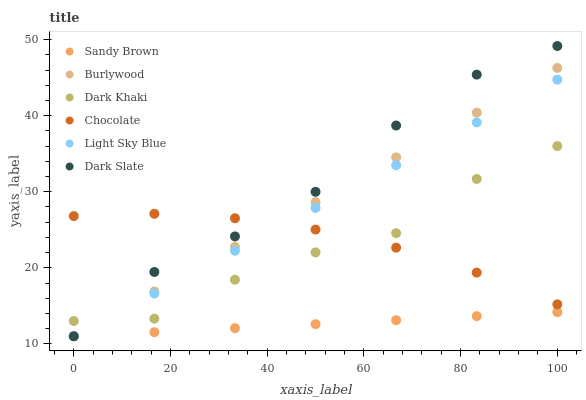Does Sandy Brown have the minimum area under the curve?
Answer yes or no. Yes. Does Dark Slate have the maximum area under the curve?
Answer yes or no. Yes. Does Chocolate have the minimum area under the curve?
Answer yes or no. No. Does Chocolate have the maximum area under the curve?
Answer yes or no. No. Is Sandy Brown the smoothest?
Answer yes or no. Yes. Is Dark Khaki the roughest?
Answer yes or no. Yes. Is Chocolate the smoothest?
Answer yes or no. No. Is Chocolate the roughest?
Answer yes or no. No. Does Burlywood have the lowest value?
Answer yes or no. Yes. Does Dark Khaki have the lowest value?
Answer yes or no. No. Does Dark Slate have the highest value?
Answer yes or no. Yes. Does Chocolate have the highest value?
Answer yes or no. No. Is Sandy Brown less than Dark Khaki?
Answer yes or no. Yes. Is Chocolate greater than Sandy Brown?
Answer yes or no. Yes. Does Dark Slate intersect Chocolate?
Answer yes or no. Yes. Is Dark Slate less than Chocolate?
Answer yes or no. No. Is Dark Slate greater than Chocolate?
Answer yes or no. No. Does Sandy Brown intersect Dark Khaki?
Answer yes or no. No. 